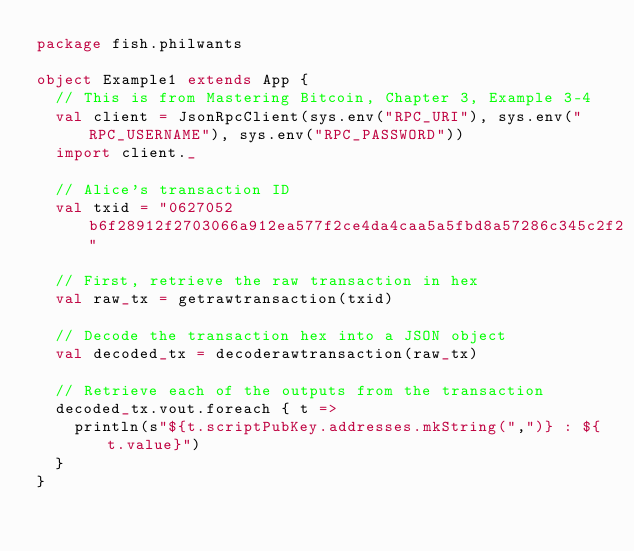<code> <loc_0><loc_0><loc_500><loc_500><_Scala_>package fish.philwants

object Example1 extends App {
  // This is from Mastering Bitcoin, Chapter 3, Example 3-4
  val client = JsonRpcClient(sys.env("RPC_URI"), sys.env("RPC_USERNAME"), sys.env("RPC_PASSWORD"))
  import client._

  // Alice's transaction ID
  val txid = "0627052b6f28912f2703066a912ea577f2ce4da4caa5a5fbd8a57286c345c2f2"

  // First, retrieve the raw transaction in hex
  val raw_tx = getrawtransaction(txid)

  // Decode the transaction hex into a JSON object
  val decoded_tx = decoderawtransaction(raw_tx)

  // Retrieve each of the outputs from the transaction
  decoded_tx.vout.foreach { t =>
    println(s"${t.scriptPubKey.addresses.mkString(",")} : ${t.value}")
  }
}
</code> 